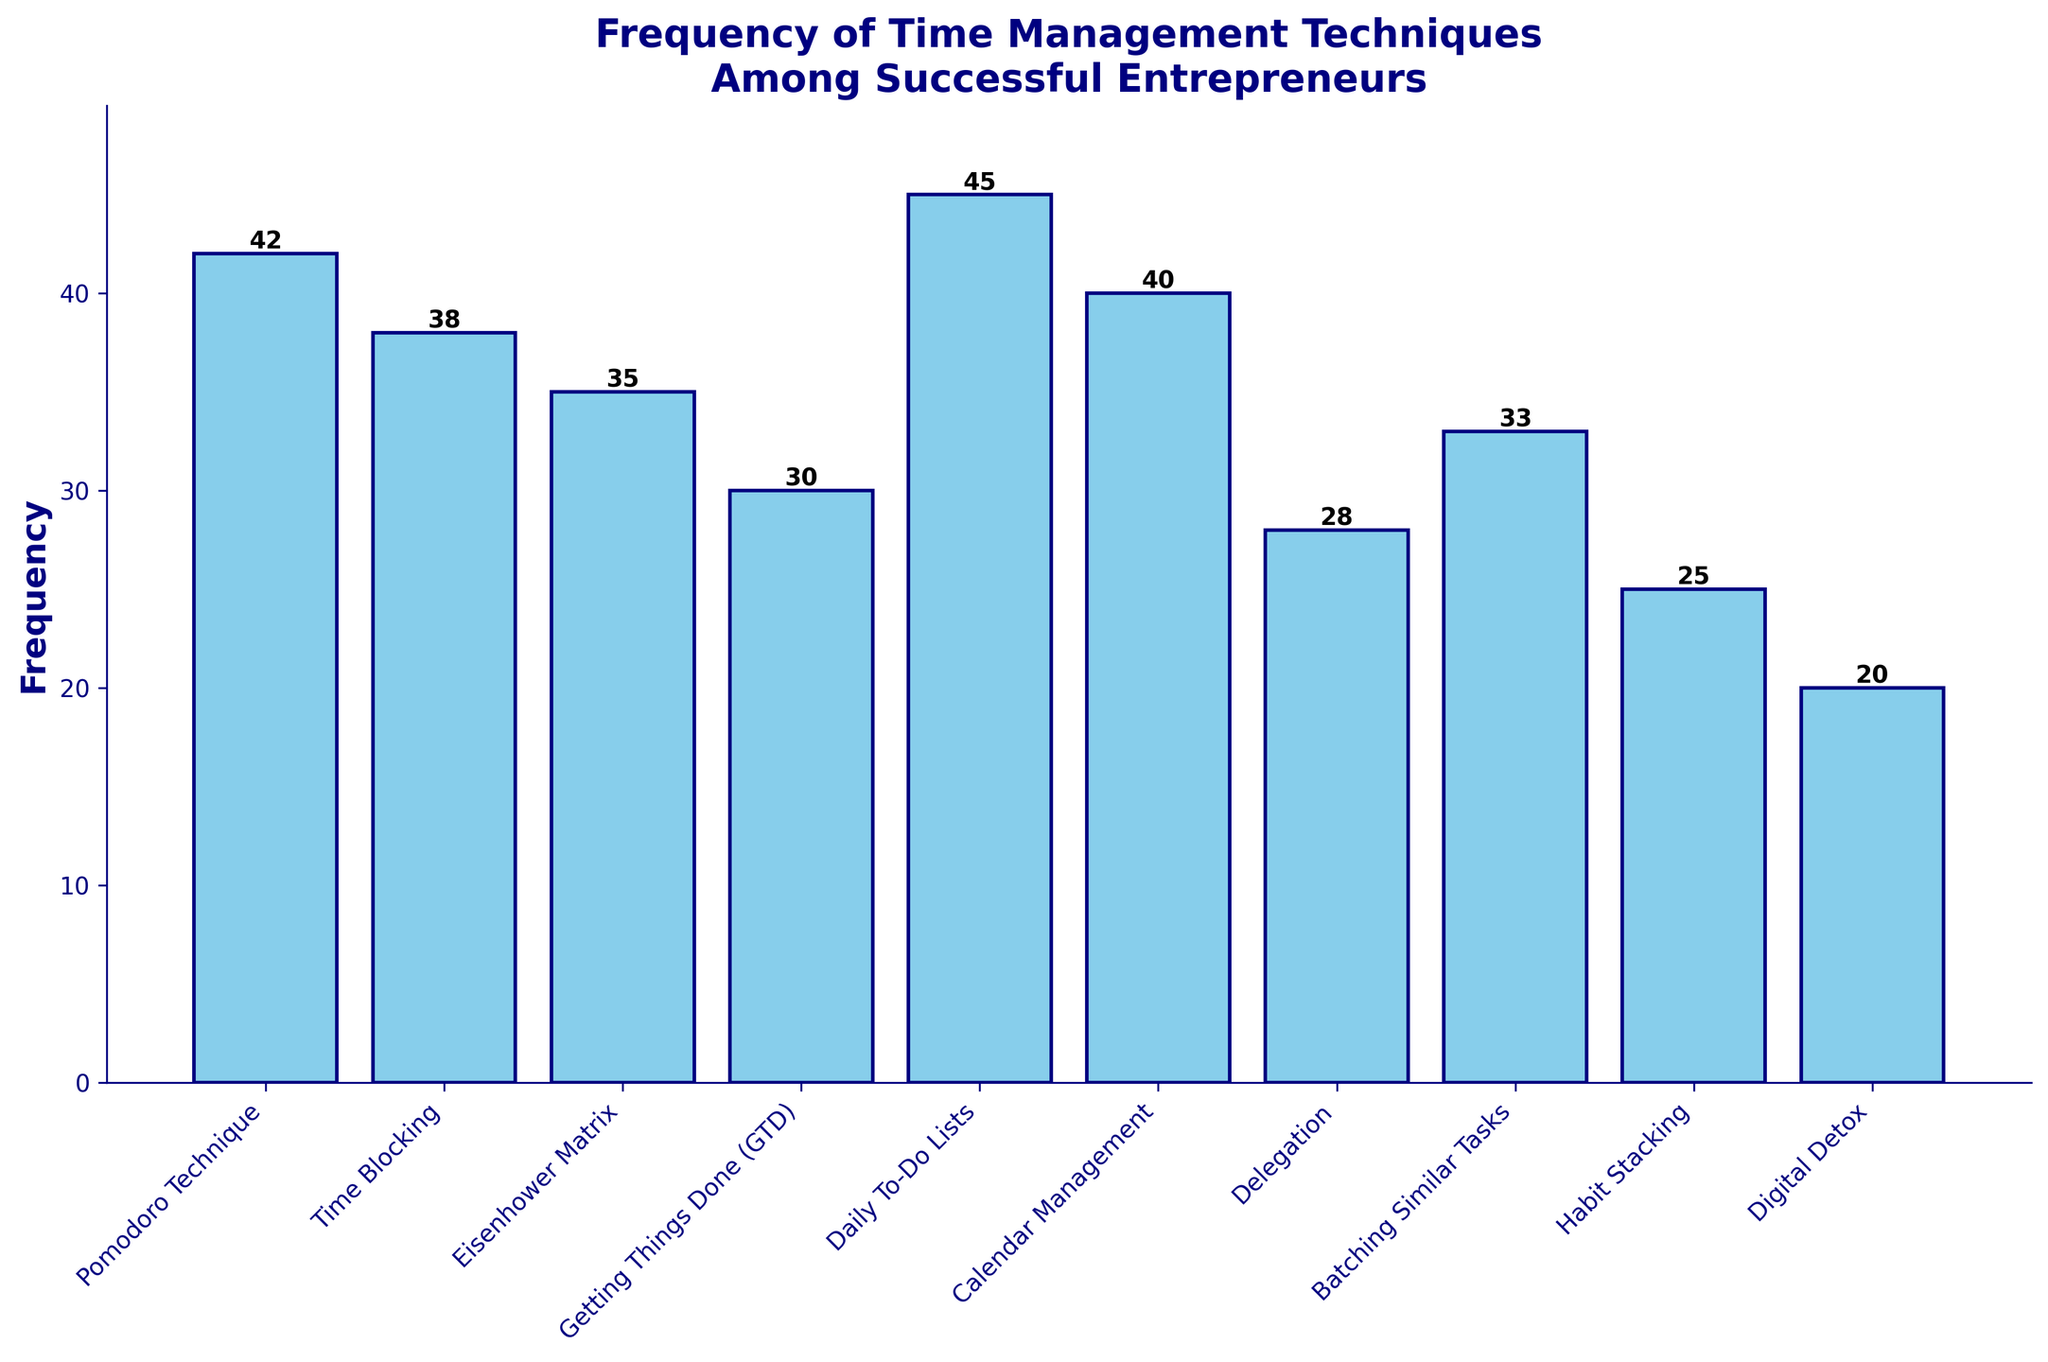Which time management technique is used the most frequently among successful entrepreneurs? Look at the tallest bar in the histogram, which is the Daily To-Do Lists at a frequency of 45.
Answer: Daily To-Do Lists What is the frequency of use for the Eisenhower Matrix technique? Refer to the height of the bar corresponding to the Eisenhower Matrix, which is 35.
Answer: 35 How does the frequency of use for Digital Detox compare to Habit Stacking? The bar for Digital Detox is at 20, whereas the bar for Habit Stacking is at 25. Therefore, Digital Detox is used 5 times less frequently than Habit Stacking.
Answer: 5 times less Which time management techniques have a frequency higher than 30? Scan the heights of each bar and find the techniques with heights greater than 30. These are Pomodoro Technique (42), Time Blocking (38), Eisenhower Matrix (35), Daily To-Do Lists (45), and Calendar Management (40).
Answer: Pomodoro Technique, Time Blocking, Eisenhower Matrix, Daily To-Do Lists, Calendar Management What is the average frequency of the techniques used? Sum all the frequencies and divide by the number of techniques. (42 + 38 + 35 + 30 + 45 + 40 + 28 + 33 + 25 + 20) / 10 = 336 / 10 = 33.6.
Answer: 33.6 Is the frequency of Delegation more or less than the average frequency of 33.6? The frequency of Delegation is 28. Compare 28 with 33.6, and we see it is less.
Answer: Less What is the total frequency of the top three most frequently used techniques? Sum the frequencies of Daily To-Do Lists, Pomodoro Technique, and Calendar Management. 45 + 42 + 40 = 127.
Answer: 127 How many techniques have a frequency of use below 30? Count the bars that represent frequencies less than 30. These techniques are Delegation (28), Habit Stacking (25), and Digital Detox (20). There are 3 of them.
Answer: 3 Which technique has the closest frequency of use to the average frequency? The average frequency is 33.6. Compare each frequency to see which is closest: Pomodoro Technique (42), Time Blocking (38), Eisenhower Matrix (35), Getting Things Done (30), Daily To-Do Lists (45), Calendar Management (40), Delegation (28), Batching Similar Tasks (33), Habit Stacking (25), and Digital Detox (20). Batching Similar Tasks with 33 is the closest.
Answer: Batching Similar Tasks 